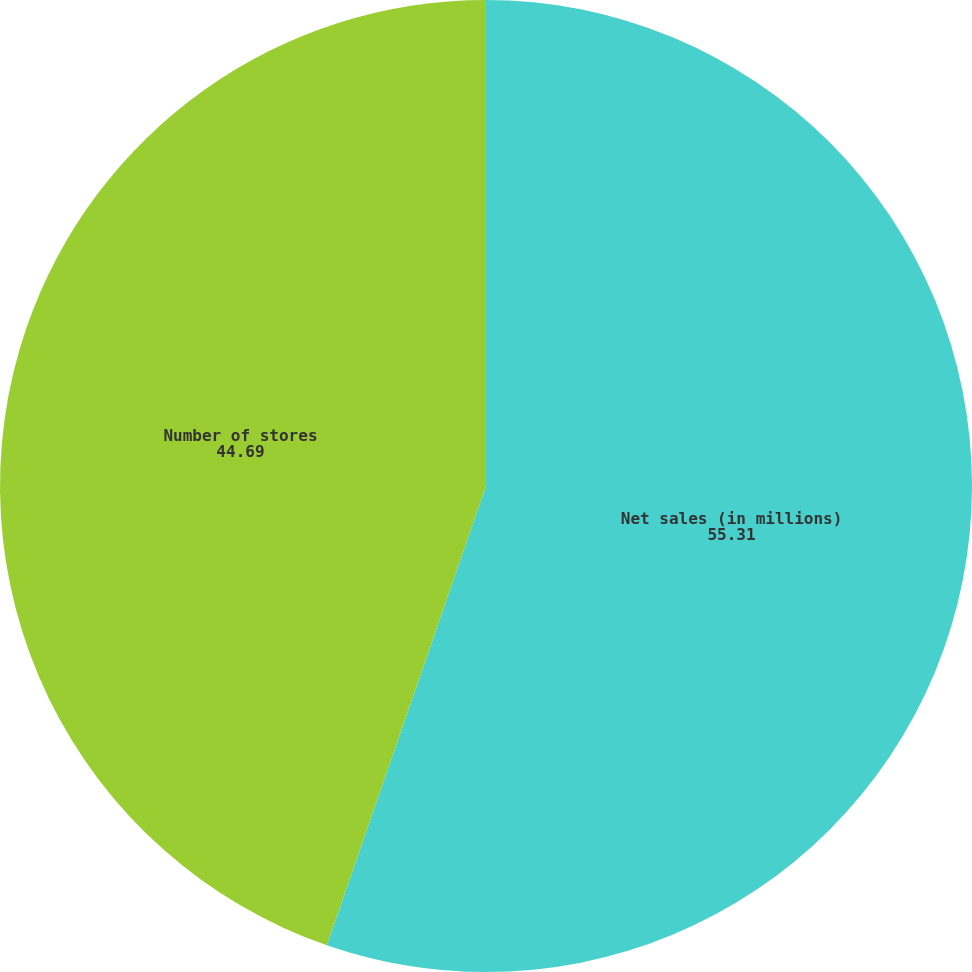<chart> <loc_0><loc_0><loc_500><loc_500><pie_chart><fcel>Net sales (in millions)<fcel>Number of stores<nl><fcel>55.31%<fcel>44.69%<nl></chart> 